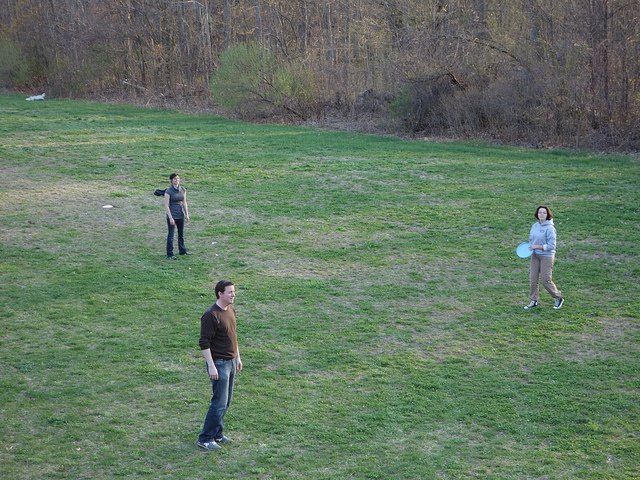Describe the objects in this image and their specific colors. I can see people in gray, black, navy, and darkgray tones, people in gray, lightblue, and darkgray tones, people in gray, black, navy, and darkgray tones, and frisbee in gray and lightblue tones in this image. 